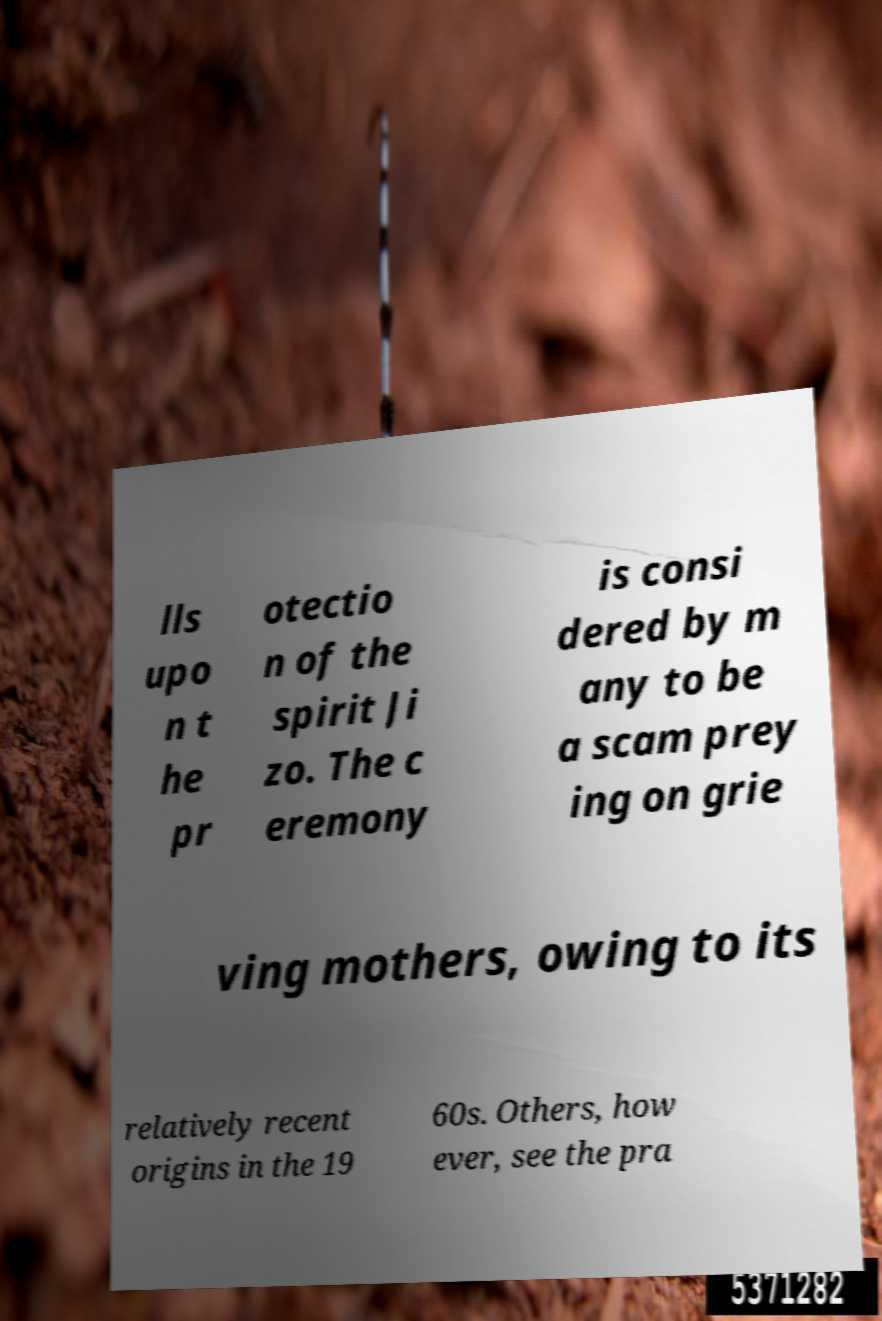What messages or text are displayed in this image? I need them in a readable, typed format. lls upo n t he pr otectio n of the spirit Ji zo. The c eremony is consi dered by m any to be a scam prey ing on grie ving mothers, owing to its relatively recent origins in the 19 60s. Others, how ever, see the pra 